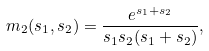Convert formula to latex. <formula><loc_0><loc_0><loc_500><loc_500>m _ { 2 } ( s _ { 1 } , s _ { 2 } ) = \frac { e ^ { s _ { 1 } + s _ { 2 } } } { s _ { 1 } s _ { 2 } ( s _ { 1 } + s _ { 2 } ) } ,</formula> 